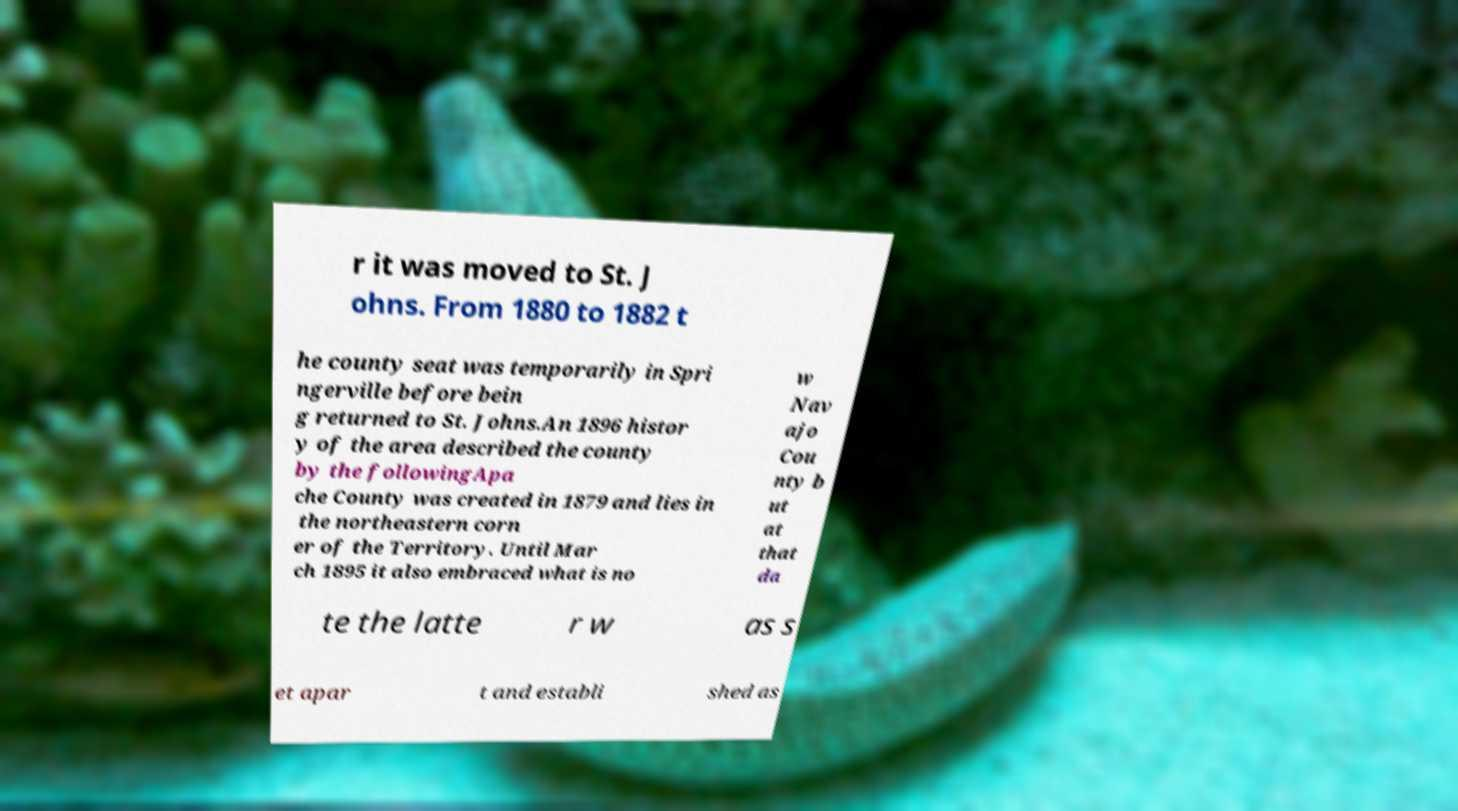For documentation purposes, I need the text within this image transcribed. Could you provide that? r it was moved to St. J ohns. From 1880 to 1882 t he county seat was temporarily in Spri ngerville before bein g returned to St. Johns.An 1896 histor y of the area described the county by the followingApa che County was created in 1879 and lies in the northeastern corn er of the Territory. Until Mar ch 1895 it also embraced what is no w Nav ajo Cou nty b ut at that da te the latte r w as s et apar t and establi shed as 